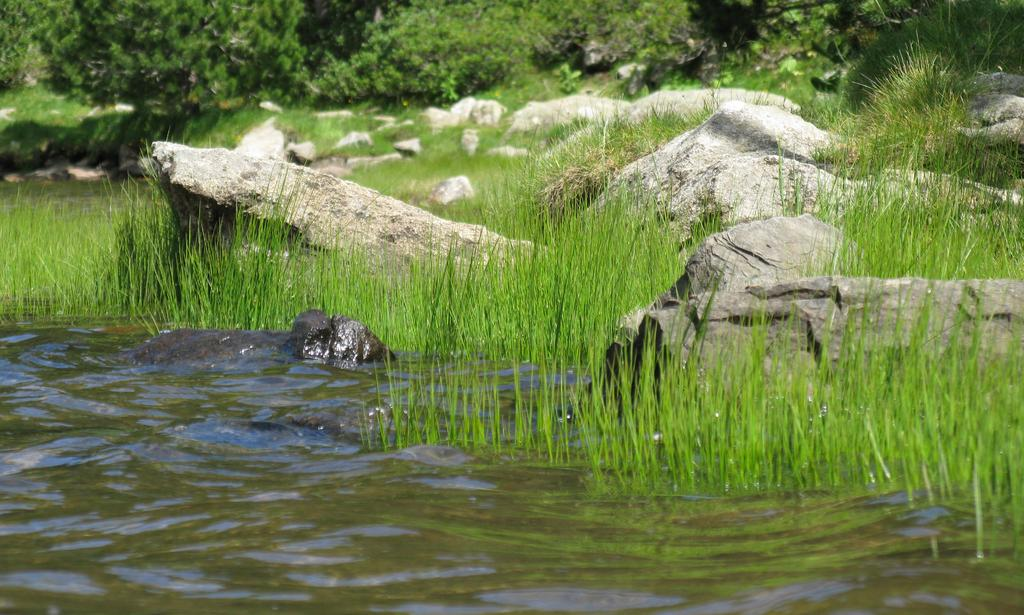What is in the water in the image? There is an animal in the water in the image. What type of vegetation is near the water? There is grass near the water in the image. What can be found on the ground in the image? There are rocks on the ground in the image. What is visible in the background of the image? There are plants and trees in the background of the image. How does the animal blow bubbles in the water in the image? The animal does not blow bubbles in the water in the image; there is no indication of this activity. 